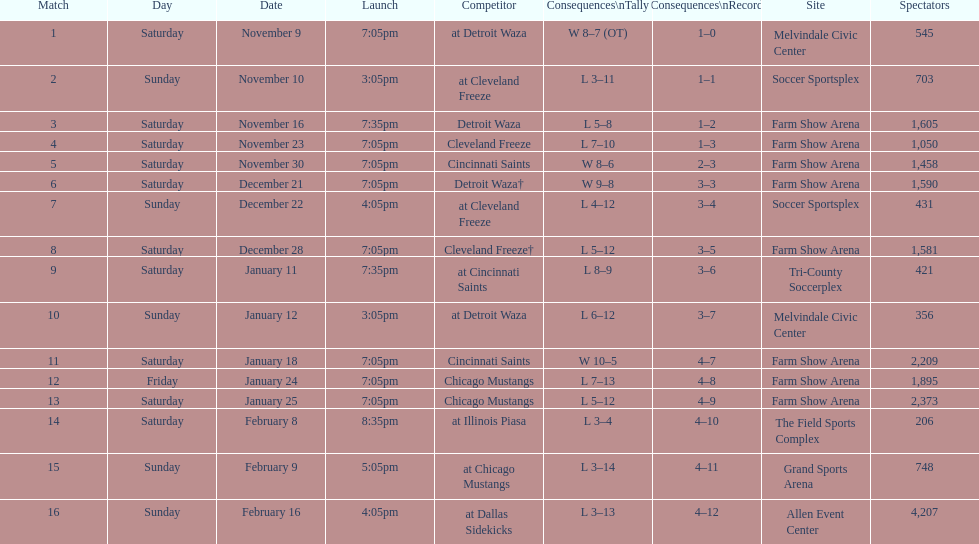How long was the teams longest losing streak? 5 games. Parse the table in full. {'header': ['Match', 'Day', 'Date', 'Launch', 'Competitor', 'Consequences\\nTally', 'Consequences\\nRecord', 'Site', 'Spectators'], 'rows': [['1', 'Saturday', 'November 9', '7:05pm', 'at Detroit Waza', 'W 8–7 (OT)', '1–0', 'Melvindale Civic Center', '545'], ['2', 'Sunday', 'November 10', '3:05pm', 'at Cleveland Freeze', 'L 3–11', '1–1', 'Soccer Sportsplex', '703'], ['3', 'Saturday', 'November 16', '7:35pm', 'Detroit Waza', 'L 5–8', '1–2', 'Farm Show Arena', '1,605'], ['4', 'Saturday', 'November 23', '7:05pm', 'Cleveland Freeze', 'L 7–10', '1–3', 'Farm Show Arena', '1,050'], ['5', 'Saturday', 'November 30', '7:05pm', 'Cincinnati Saints', 'W 8–6', '2–3', 'Farm Show Arena', '1,458'], ['6', 'Saturday', 'December 21', '7:05pm', 'Detroit Waza†', 'W 9–8', '3–3', 'Farm Show Arena', '1,590'], ['7', 'Sunday', 'December 22', '4:05pm', 'at Cleveland Freeze', 'L 4–12', '3–4', 'Soccer Sportsplex', '431'], ['8', 'Saturday', 'December 28', '7:05pm', 'Cleveland Freeze†', 'L 5–12', '3–5', 'Farm Show Arena', '1,581'], ['9', 'Saturday', 'January 11', '7:35pm', 'at Cincinnati Saints', 'L 8–9', '3–6', 'Tri-County Soccerplex', '421'], ['10', 'Sunday', 'January 12', '3:05pm', 'at Detroit Waza', 'L 6–12', '3–7', 'Melvindale Civic Center', '356'], ['11', 'Saturday', 'January 18', '7:05pm', 'Cincinnati Saints', 'W 10–5', '4–7', 'Farm Show Arena', '2,209'], ['12', 'Friday', 'January 24', '7:05pm', 'Chicago Mustangs', 'L 7–13', '4–8', 'Farm Show Arena', '1,895'], ['13', 'Saturday', 'January 25', '7:05pm', 'Chicago Mustangs', 'L 5–12', '4–9', 'Farm Show Arena', '2,373'], ['14', 'Saturday', 'February 8', '8:35pm', 'at Illinois Piasa', 'L 3–4', '4–10', 'The Field Sports Complex', '206'], ['15', 'Sunday', 'February 9', '5:05pm', 'at Chicago Mustangs', 'L 3–14', '4–11', 'Grand Sports Arena', '748'], ['16', 'Sunday', 'February 16', '4:05pm', 'at Dallas Sidekicks', 'L 3–13', '4–12', 'Allen Event Center', '4,207']]} 